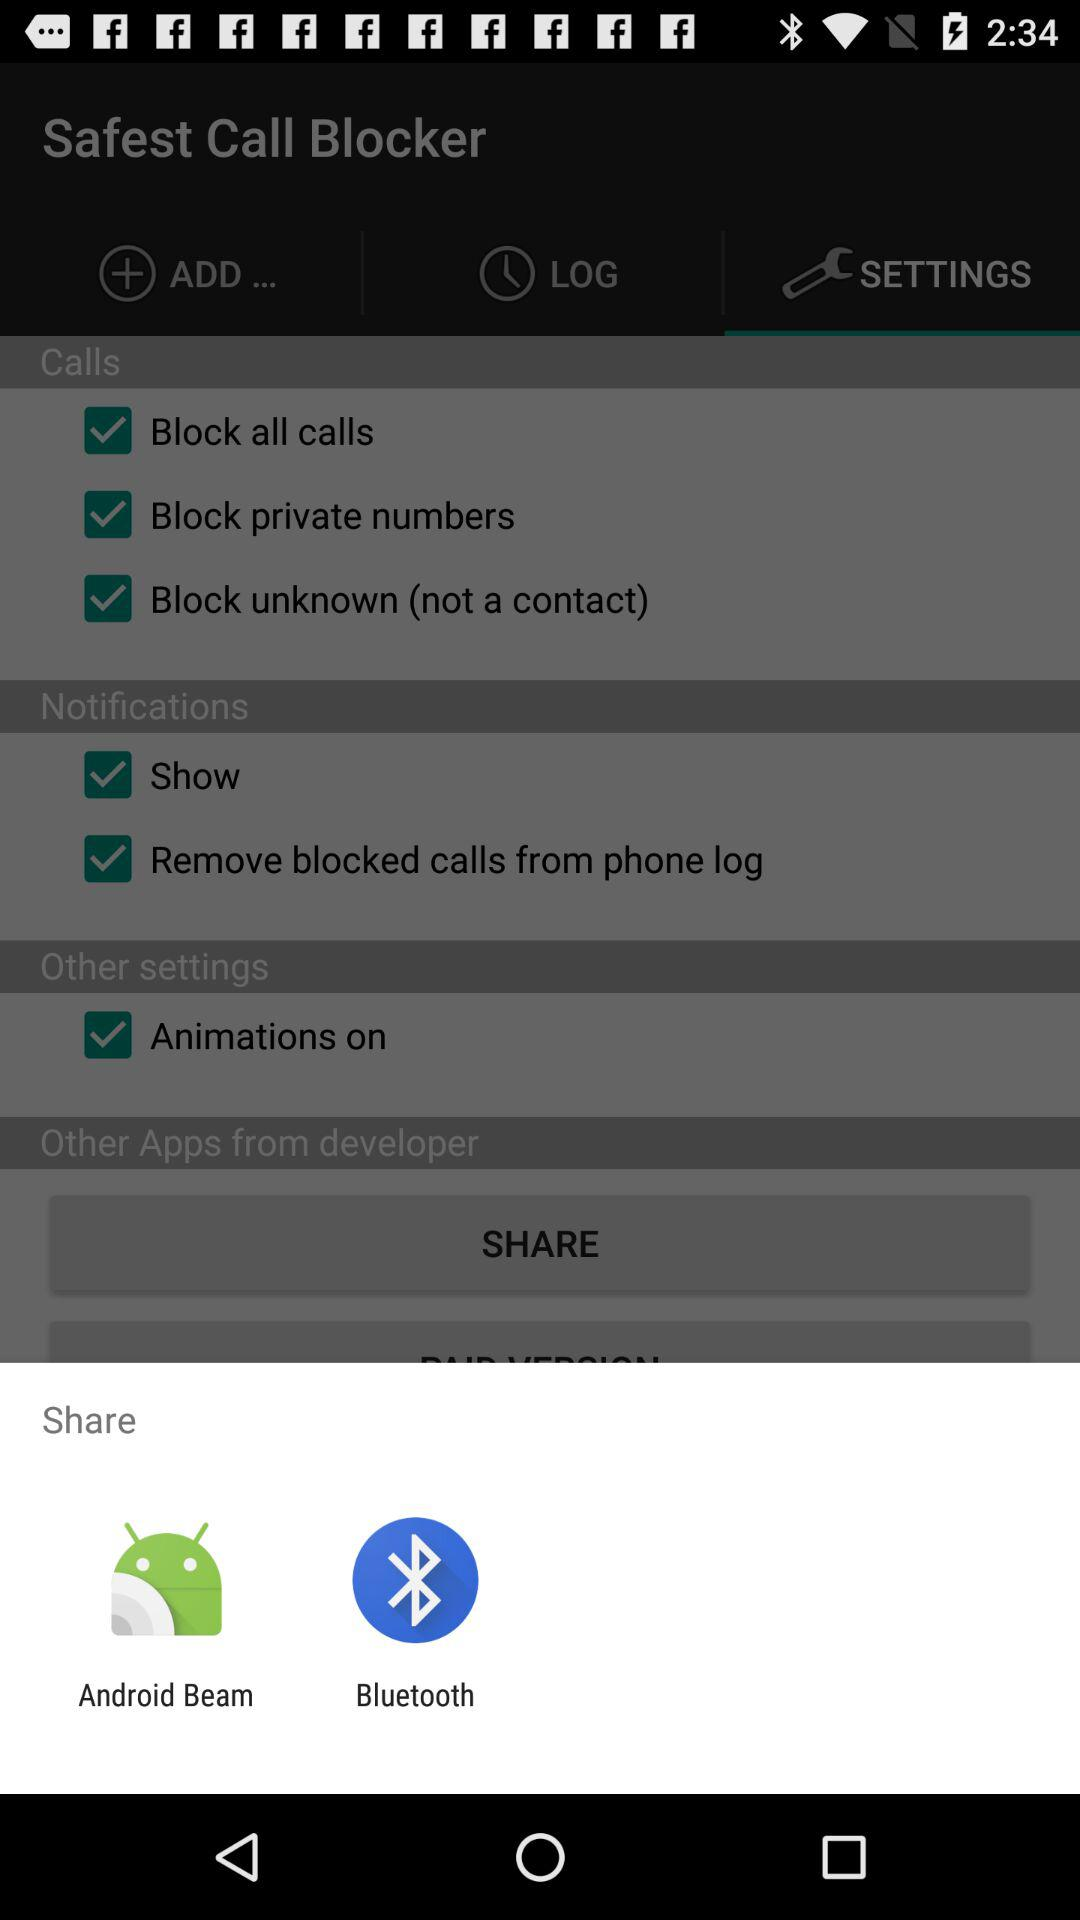How many checkbox labels are in the 'Notifications' section?
Answer the question using a single word or phrase. 2 